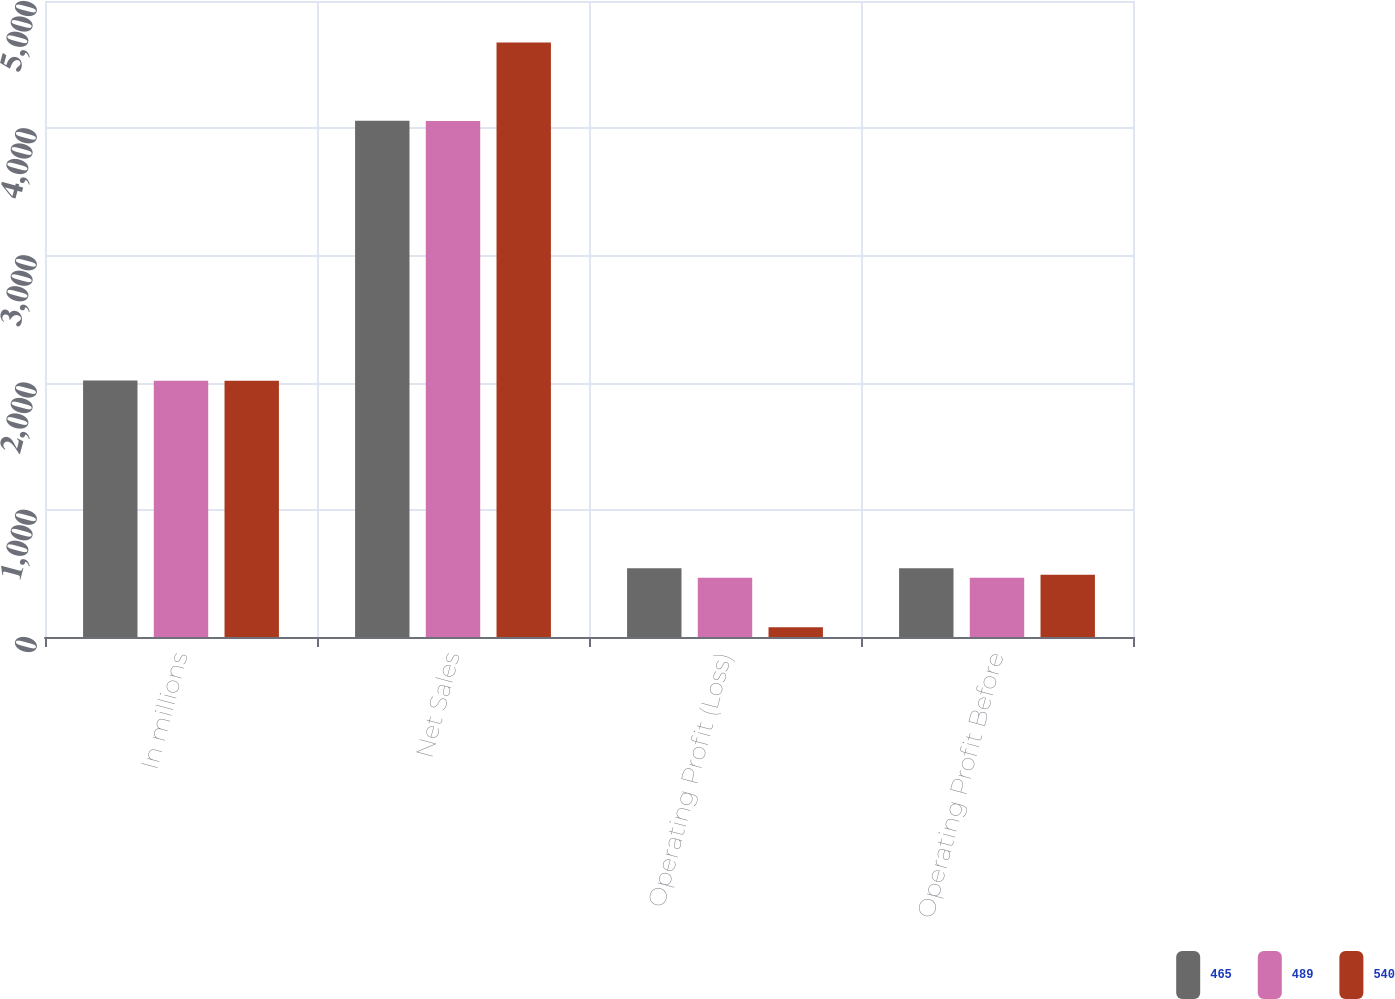<chart> <loc_0><loc_0><loc_500><loc_500><stacked_bar_chart><ecel><fcel>In millions<fcel>Net Sales<fcel>Operating Profit (Loss)<fcel>Operating Profit Before<nl><fcel>465<fcel>2016<fcel>4058<fcel>540<fcel>540<nl><fcel>489<fcel>2015<fcel>4056<fcel>465<fcel>465<nl><fcel>540<fcel>2014<fcel>4674<fcel>77<fcel>489<nl></chart> 